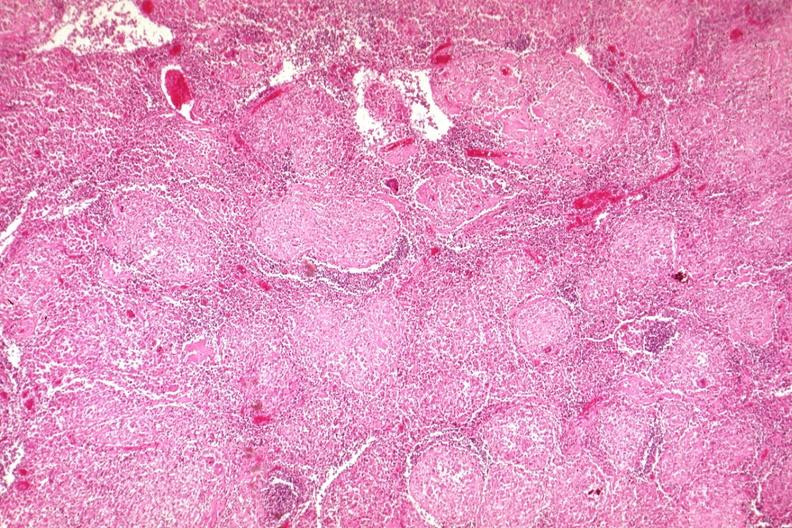does this image show typical granulomas?
Answer the question using a single word or phrase. Yes 